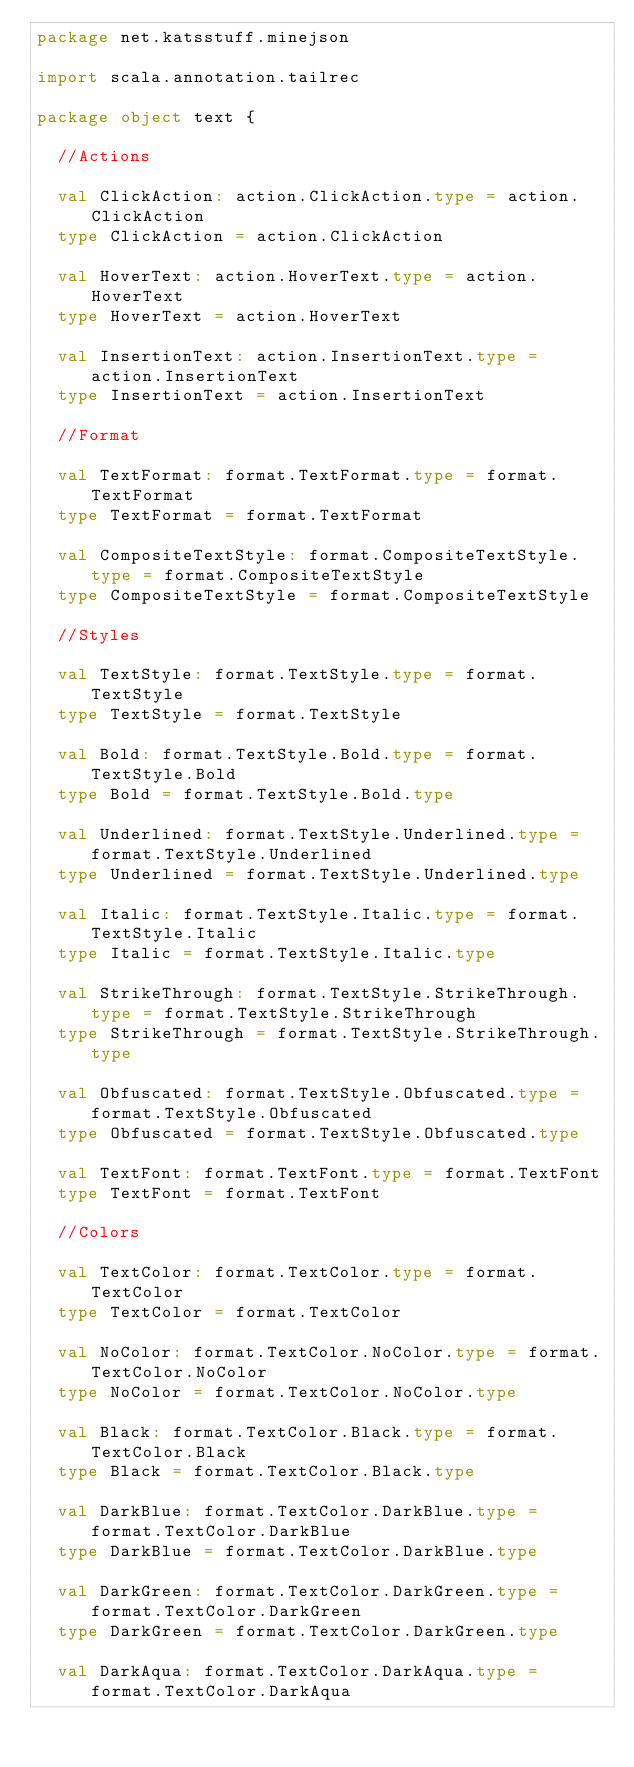Convert code to text. <code><loc_0><loc_0><loc_500><loc_500><_Scala_>package net.katsstuff.minejson

import scala.annotation.tailrec

package object text {

  //Actions

  val ClickAction: action.ClickAction.type = action.ClickAction
  type ClickAction = action.ClickAction

  val HoverText: action.HoverText.type = action.HoverText
  type HoverText = action.HoverText

  val InsertionText: action.InsertionText.type = action.InsertionText
  type InsertionText = action.InsertionText

  //Format

  val TextFormat: format.TextFormat.type = format.TextFormat
  type TextFormat = format.TextFormat

  val CompositeTextStyle: format.CompositeTextStyle.type = format.CompositeTextStyle
  type CompositeTextStyle = format.CompositeTextStyle

  //Styles

  val TextStyle: format.TextStyle.type = format.TextStyle
  type TextStyle = format.TextStyle

  val Bold: format.TextStyle.Bold.type = format.TextStyle.Bold
  type Bold = format.TextStyle.Bold.type

  val Underlined: format.TextStyle.Underlined.type = format.TextStyle.Underlined
  type Underlined = format.TextStyle.Underlined.type

  val Italic: format.TextStyle.Italic.type = format.TextStyle.Italic
  type Italic = format.TextStyle.Italic.type

  val StrikeThrough: format.TextStyle.StrikeThrough.type = format.TextStyle.StrikeThrough
  type StrikeThrough = format.TextStyle.StrikeThrough.type

  val Obfuscated: format.TextStyle.Obfuscated.type = format.TextStyle.Obfuscated
  type Obfuscated = format.TextStyle.Obfuscated.type

  val TextFont: format.TextFont.type = format.TextFont
  type TextFont = format.TextFont

  //Colors

  val TextColor: format.TextColor.type = format.TextColor
  type TextColor = format.TextColor

  val NoColor: format.TextColor.NoColor.type = format.TextColor.NoColor
  type NoColor = format.TextColor.NoColor.type

  val Black: format.TextColor.Black.type = format.TextColor.Black
  type Black = format.TextColor.Black.type

  val DarkBlue: format.TextColor.DarkBlue.type = format.TextColor.DarkBlue
  type DarkBlue = format.TextColor.DarkBlue.type

  val DarkGreen: format.TextColor.DarkGreen.type = format.TextColor.DarkGreen
  type DarkGreen = format.TextColor.DarkGreen.type

  val DarkAqua: format.TextColor.DarkAqua.type = format.TextColor.DarkAqua</code> 